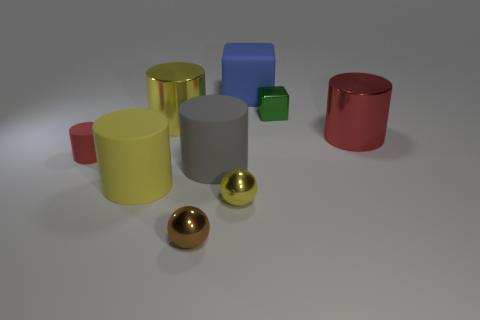There is a large shiny cylinder right of the small brown ball; is its color the same as the small rubber object?
Your response must be concise. Yes. What size is the green metallic cube to the right of the yellow cylinder behind the red rubber cylinder?
Keep it short and to the point. Small. Is the color of the small cylinder the same as the metal thing that is right of the green object?
Offer a terse response. Yes. What number of other objects are there of the same material as the large gray thing?
Provide a succinct answer. 3. What shape is the tiny yellow thing that is made of the same material as the green block?
Offer a terse response. Sphere. Is there any other thing that is the same color as the tiny matte cylinder?
Ensure brevity in your answer.  Yes. There is a thing that is the same color as the tiny cylinder; what is its size?
Offer a terse response. Large. Is the number of red things that are on the left side of the tiny brown shiny thing greater than the number of gray metallic balls?
Offer a terse response. Yes. Is the shape of the red shiny thing the same as the large metal object left of the big block?
Provide a succinct answer. Yes. What number of cylinders have the same size as the brown ball?
Keep it short and to the point. 1. 